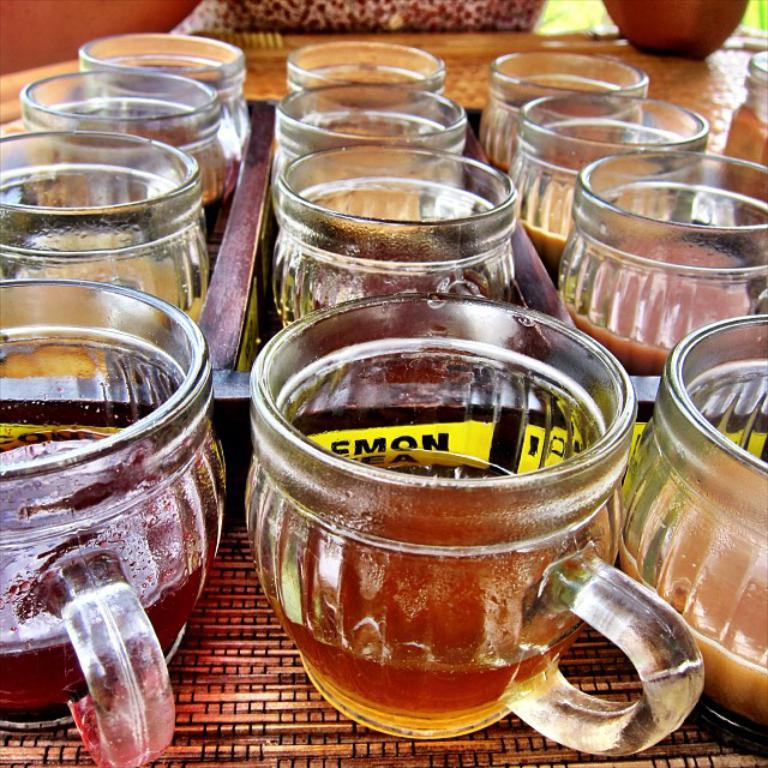What is contained in the cups that are visible in the image? There are cups with liquid in the image. How are the cups arranged in the image? The cups are arranged in an order on a tray. Where is the tray with cups located in the image? The tray with cups is on a table. What can be seen in the background of the image? There are objects visible in the background of the image. What is the price of the gun visible in the image? There is no gun present in the image, so it is not possible to determine its price. 